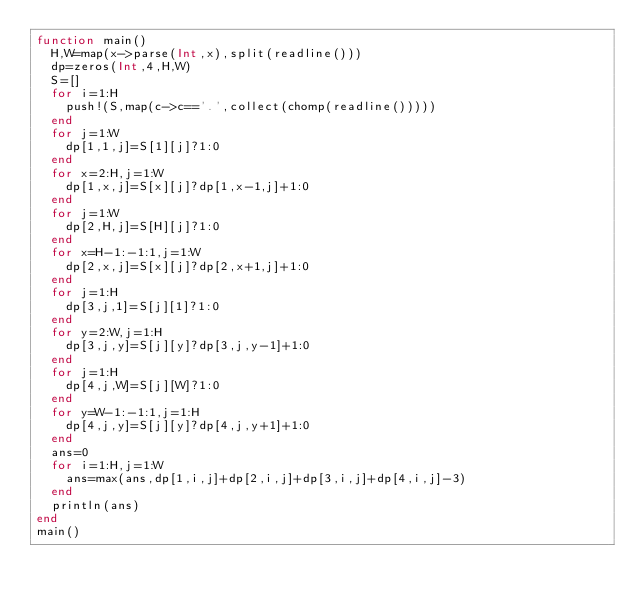<code> <loc_0><loc_0><loc_500><loc_500><_Julia_>function main()
	H,W=map(x->parse(Int,x),split(readline()))
	dp=zeros(Int,4,H,W)
	S=[]
	for i=1:H
		push!(S,map(c->c=='.',collect(chomp(readline()))))
	end
	for j=1:W
		dp[1,1,j]=S[1][j]?1:0
	end
	for x=2:H,j=1:W
		dp[1,x,j]=S[x][j]?dp[1,x-1,j]+1:0
	end
	for j=1:W
		dp[2,H,j]=S[H][j]?1:0
	end
	for x=H-1:-1:1,j=1:W
		dp[2,x,j]=S[x][j]?dp[2,x+1,j]+1:0
	end
	for j=1:H
		dp[3,j,1]=S[j][1]?1:0
	end
	for y=2:W,j=1:H
		dp[3,j,y]=S[j][y]?dp[3,j,y-1]+1:0
	end
	for j=1:H
		dp[4,j,W]=S[j][W]?1:0
	end
	for y=W-1:-1:1,j=1:H
		dp[4,j,y]=S[j][y]?dp[4,j,y+1]+1:0
	end
	ans=0
	for i=1:H,j=1:W
		ans=max(ans,dp[1,i,j]+dp[2,i,j]+dp[3,i,j]+dp[4,i,j]-3)
	end
	println(ans)
end
main()
</code> 